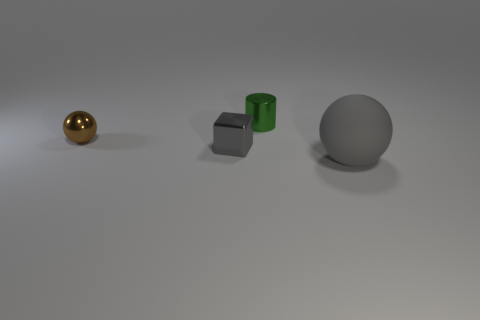Is there any other thing that has the same size as the gray rubber thing?
Your answer should be compact. No. What number of other tiny objects are the same shape as the matte thing?
Keep it short and to the point. 1. Do the large sphere and the cube have the same color?
Keep it short and to the point. Yes. Are there fewer small metallic cubes than small objects?
Offer a terse response. Yes. What is the material of the gray object that is left of the big gray object?
Keep it short and to the point. Metal. What is the material of the brown ball that is the same size as the cube?
Provide a short and direct response. Metal. What is the material of the sphere that is behind the tiny object that is in front of the small brown metal object that is left of the gray cube?
Offer a very short reply. Metal. There is a brown object that is in front of the shiny cylinder; is its size the same as the tiny green object?
Keep it short and to the point. Yes. Are there more tiny brown spheres than red rubber things?
Offer a very short reply. Yes. What number of small things are gray spheres or green metallic things?
Provide a succinct answer. 1. 